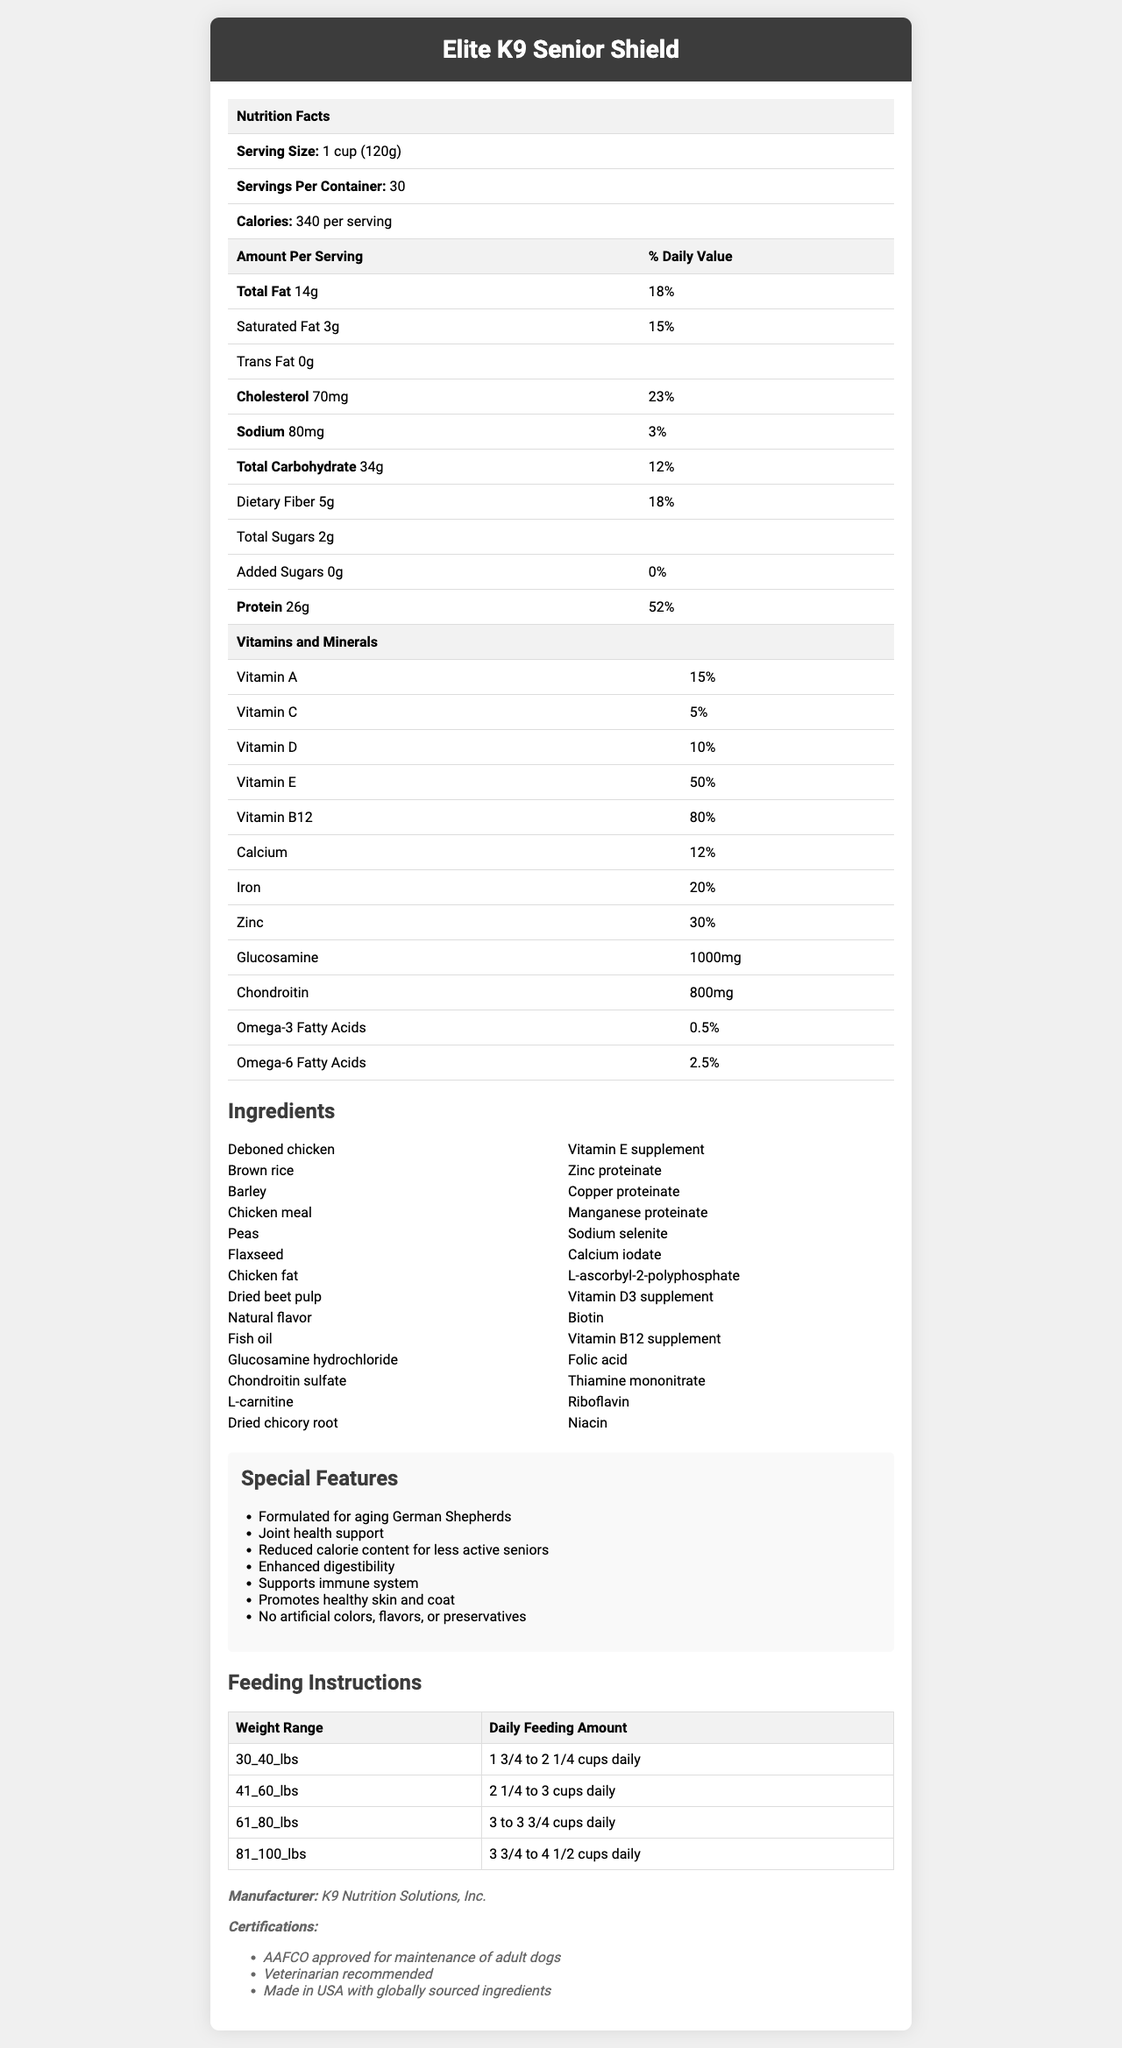what is the serving size for Elite K9 Senior Shield? The serving size is listed at the top of the nutrition facts table under "Serving Size."
Answer: 1 cup (120g) How many calories are in one serving? The number of calories per serving is stated in the nutrition facts table under "Calories."
Answer: 340 calories How much protein does one serving contain? The amount of protein per serving is shown in the nutrition facts table under "Amount Per Serving."
Answer: 26g What percentage of the daily value of Vitamin B12 does one serving provide? The percentage of the daily value for Vitamin B12 is listed in the vitamins and minerals table.
Answer: 80% What is the daily recommended feeding amount for a dog weighing 50 lbs? The feeding instructions table provides daily feeding amounts based on weight ranges.
Answer: 2 1/4 to 3 cups daily Does the dog food contain any trans fats? The nutrition facts table lists trans fat as 0g under "Trans Fat."
Answer: No Which ingredient is listed first? Deboned chicken is the first ingredient listed in the ingredients section.
Answer: Deboned chicken Which feature is not included in Elite K9 Senior Shield? A. Joint health support B. Weight gain support C. Enhanced digestibility Among the special features listed, "Weight gain support" is not included.
Answer: B What is the daily value percentage for saturated fat? The daily value percentage for saturated fat is listed under "Saturated Fat" in the nutrition facts table.
Answer: 15% Which certification does not apply to this product? A. AAFCO approved B. USDA Organic C. Veterinarian recommended Among the certifications listed, "USDA Organic" is not mentioned.
Answer: B Is this dog food made in the USA? The certification section states that it is "Made in USA with globally sourced ingredients."
Answer: Yes What is the purpose of glucosamine in the dog food? Glucosamine is included in the vitamins and minerals section, and joint health support is listed in the special features.
Answer: Joint health support How many servings are there in one container? The number of servings per container is stated in the nutrition facts table.
Answer: 30 What are the two main macronutrients contributing to the calorie content per serving? A. Total Fat and Protein B. Total Fat and Carbohydrate C. Carbohydrate and Protein Total Fat (14g) and Protein (26g) are the primary macronutrients contributing to the calorie count.
Answer: A Which vitamin has the highest daily value percentage? Vitamin B12 has the highest daily value percentage of 80%, as listed in the vitamins and minerals table.
Answer: Vitamin B12 Does this dog food contain artificial colors or preservatives? The special features list states "No artificial colors, flavors, or preservatives."
Answer: No Summarize the purpose and key features of the Elite K9 Senior Shield dog food. The document provides detailed nutrition facts, ingredient lists, special features, feeding instructions, and certifications for the Elite K9 Senior Shield dog food.
Answer: Elite K9 Senior Shield is a veterinarian-approved senior dog food formulated specifically for aging German Shepherds with reduced activity levels. Key features include joint health support from glucosamine and chondroitin, reduced calorie content for less active seniors, enhanced digestibility, immune system support, and promotion of healthy skin and coat. The product contains no artificial colors, flavors, or preservatives and is made in the USA with globally sourced ingredients. What is the manufacturer's contact information? The document does not provide any contact information for the manufacturer, K9 Nutrition Solutions, Inc.
Answer: Not enough information 